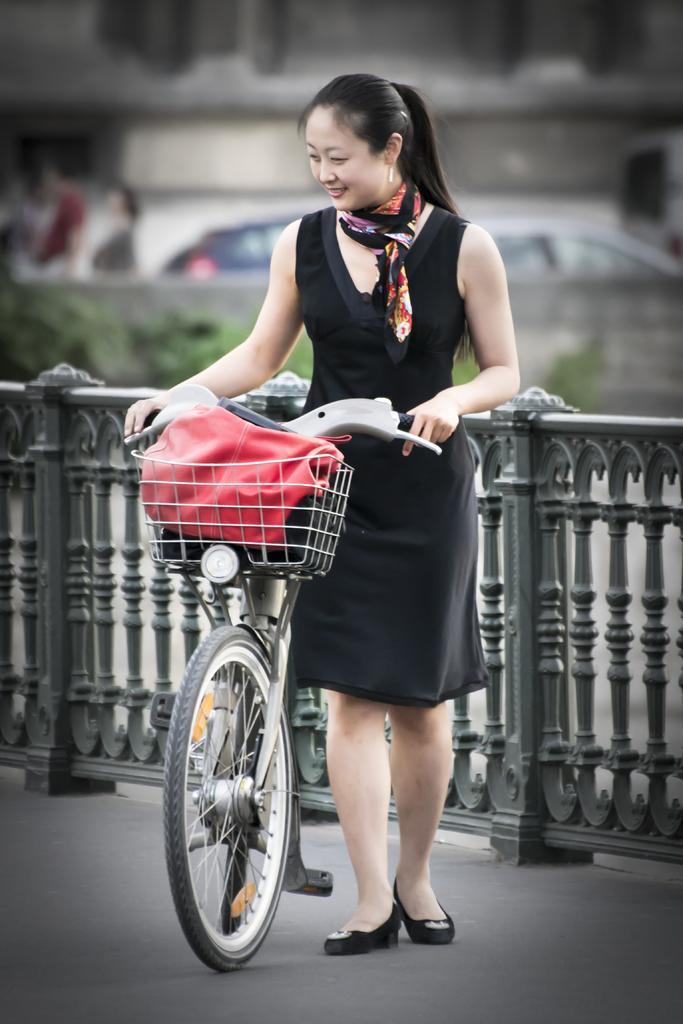Please provide a concise description of this image. In this image we can see there is a girl wearing black dress is holding a handle of a bicycle is standing on the road, beside the girl there is a railing. The background is blurred. 